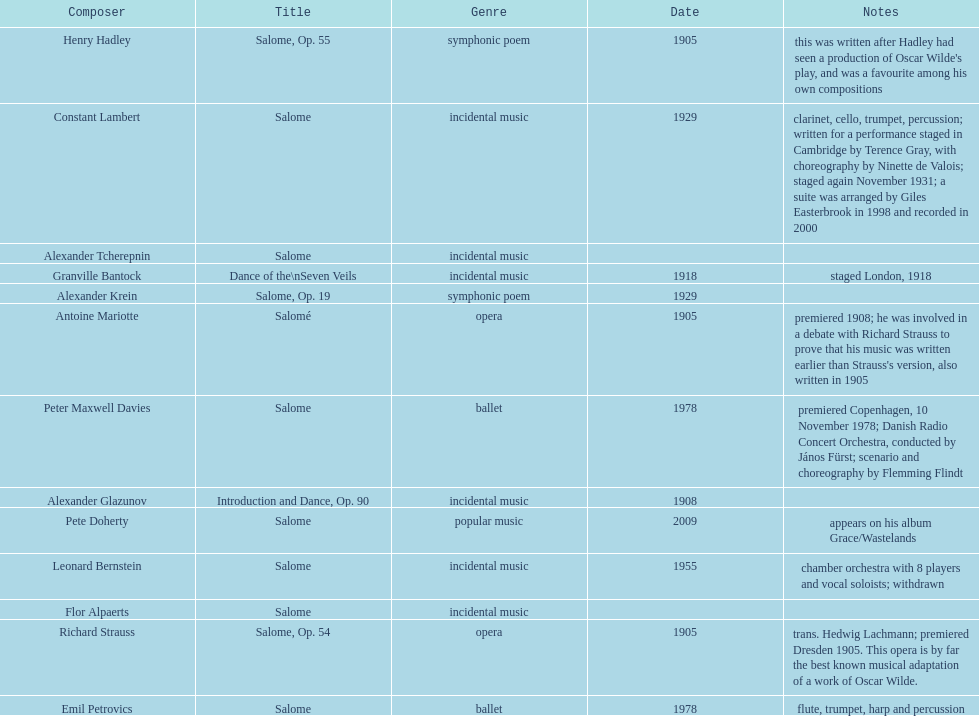Which composer published first granville bantock or emil petrovics? Granville Bantock. 